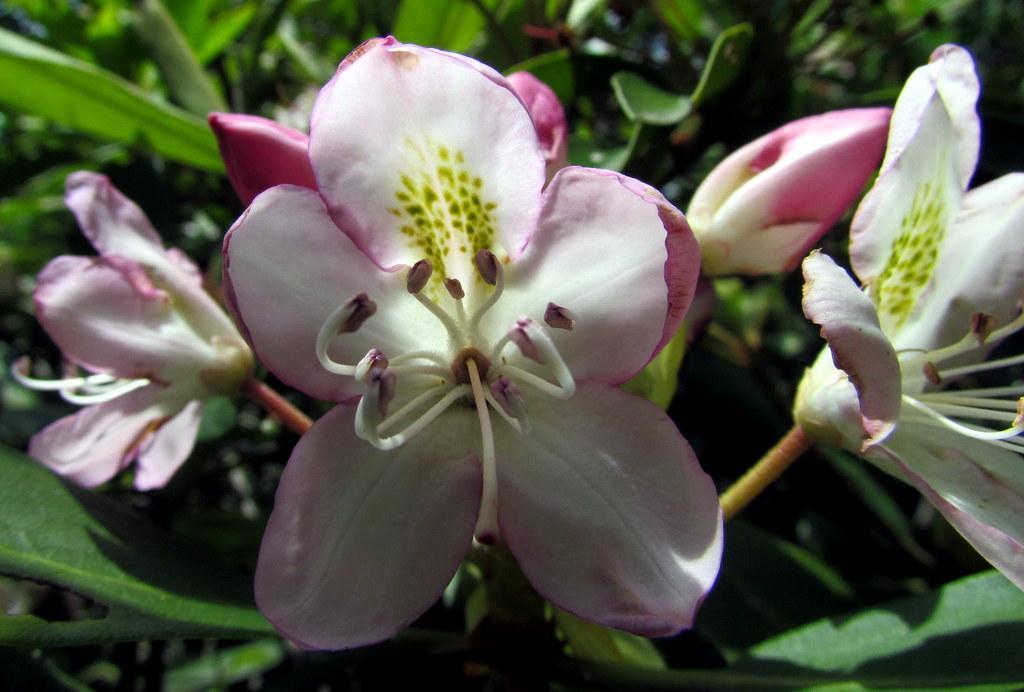In one or two sentences, can you explain what this image depicts? In this picture we can observe pink and white color flowers. There are flower buds on this flower. In the background we can observe plants which are in green color. 